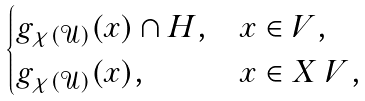Convert formula to latex. <formula><loc_0><loc_0><loc_500><loc_500>\begin{cases} g _ { \chi ( \mathcal { U } ) } ( x ) \cap H , & x \in V , \\ g _ { \chi ( \mathcal { U } ) } ( x ) , & x \in X \ V , \end{cases}</formula> 